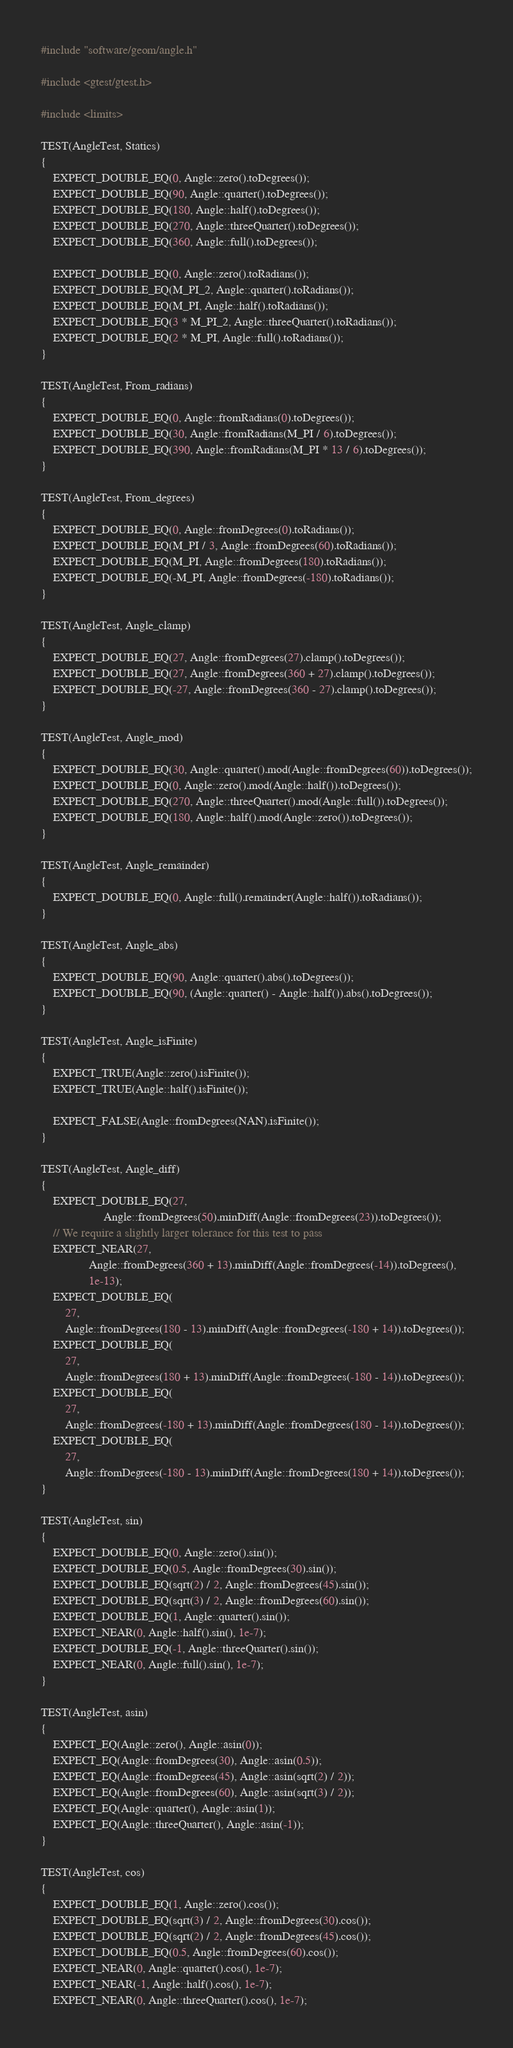<code> <loc_0><loc_0><loc_500><loc_500><_C++_>#include "software/geom/angle.h"

#include <gtest/gtest.h>

#include <limits>

TEST(AngleTest, Statics)
{
    EXPECT_DOUBLE_EQ(0, Angle::zero().toDegrees());
    EXPECT_DOUBLE_EQ(90, Angle::quarter().toDegrees());
    EXPECT_DOUBLE_EQ(180, Angle::half().toDegrees());
    EXPECT_DOUBLE_EQ(270, Angle::threeQuarter().toDegrees());
    EXPECT_DOUBLE_EQ(360, Angle::full().toDegrees());

    EXPECT_DOUBLE_EQ(0, Angle::zero().toRadians());
    EXPECT_DOUBLE_EQ(M_PI_2, Angle::quarter().toRadians());
    EXPECT_DOUBLE_EQ(M_PI, Angle::half().toRadians());
    EXPECT_DOUBLE_EQ(3 * M_PI_2, Angle::threeQuarter().toRadians());
    EXPECT_DOUBLE_EQ(2 * M_PI, Angle::full().toRadians());
}

TEST(AngleTest, From_radians)
{
    EXPECT_DOUBLE_EQ(0, Angle::fromRadians(0).toDegrees());
    EXPECT_DOUBLE_EQ(30, Angle::fromRadians(M_PI / 6).toDegrees());
    EXPECT_DOUBLE_EQ(390, Angle::fromRadians(M_PI * 13 / 6).toDegrees());
}

TEST(AngleTest, From_degrees)
{
    EXPECT_DOUBLE_EQ(0, Angle::fromDegrees(0).toRadians());
    EXPECT_DOUBLE_EQ(M_PI / 3, Angle::fromDegrees(60).toRadians());
    EXPECT_DOUBLE_EQ(M_PI, Angle::fromDegrees(180).toRadians());
    EXPECT_DOUBLE_EQ(-M_PI, Angle::fromDegrees(-180).toRadians());
}

TEST(AngleTest, Angle_clamp)
{
    EXPECT_DOUBLE_EQ(27, Angle::fromDegrees(27).clamp().toDegrees());
    EXPECT_DOUBLE_EQ(27, Angle::fromDegrees(360 + 27).clamp().toDegrees());
    EXPECT_DOUBLE_EQ(-27, Angle::fromDegrees(360 - 27).clamp().toDegrees());
}

TEST(AngleTest, Angle_mod)
{
    EXPECT_DOUBLE_EQ(30, Angle::quarter().mod(Angle::fromDegrees(60)).toDegrees());
    EXPECT_DOUBLE_EQ(0, Angle::zero().mod(Angle::half()).toDegrees());
    EXPECT_DOUBLE_EQ(270, Angle::threeQuarter().mod(Angle::full()).toDegrees());
    EXPECT_DOUBLE_EQ(180, Angle::half().mod(Angle::zero()).toDegrees());
}

TEST(AngleTest, Angle_remainder)
{
    EXPECT_DOUBLE_EQ(0, Angle::full().remainder(Angle::half()).toRadians());
}

TEST(AngleTest, Angle_abs)
{
    EXPECT_DOUBLE_EQ(90, Angle::quarter().abs().toDegrees());
    EXPECT_DOUBLE_EQ(90, (Angle::quarter() - Angle::half()).abs().toDegrees());
}

TEST(AngleTest, Angle_isFinite)
{
    EXPECT_TRUE(Angle::zero().isFinite());
    EXPECT_TRUE(Angle::half().isFinite());

    EXPECT_FALSE(Angle::fromDegrees(NAN).isFinite());
}

TEST(AngleTest, Angle_diff)
{
    EXPECT_DOUBLE_EQ(27,
                     Angle::fromDegrees(50).minDiff(Angle::fromDegrees(23)).toDegrees());
    // We require a slightly larger tolerance for this test to pass
    EXPECT_NEAR(27,
                Angle::fromDegrees(360 + 13).minDiff(Angle::fromDegrees(-14)).toDegrees(),
                1e-13);
    EXPECT_DOUBLE_EQ(
        27,
        Angle::fromDegrees(180 - 13).minDiff(Angle::fromDegrees(-180 + 14)).toDegrees());
    EXPECT_DOUBLE_EQ(
        27,
        Angle::fromDegrees(180 + 13).minDiff(Angle::fromDegrees(-180 - 14)).toDegrees());
    EXPECT_DOUBLE_EQ(
        27,
        Angle::fromDegrees(-180 + 13).minDiff(Angle::fromDegrees(180 - 14)).toDegrees());
    EXPECT_DOUBLE_EQ(
        27,
        Angle::fromDegrees(-180 - 13).minDiff(Angle::fromDegrees(180 + 14)).toDegrees());
}

TEST(AngleTest, sin)
{
    EXPECT_DOUBLE_EQ(0, Angle::zero().sin());
    EXPECT_DOUBLE_EQ(0.5, Angle::fromDegrees(30).sin());
    EXPECT_DOUBLE_EQ(sqrt(2) / 2, Angle::fromDegrees(45).sin());
    EXPECT_DOUBLE_EQ(sqrt(3) / 2, Angle::fromDegrees(60).sin());
    EXPECT_DOUBLE_EQ(1, Angle::quarter().sin());
    EXPECT_NEAR(0, Angle::half().sin(), 1e-7);
    EXPECT_DOUBLE_EQ(-1, Angle::threeQuarter().sin());
    EXPECT_NEAR(0, Angle::full().sin(), 1e-7);
}

TEST(AngleTest, asin)
{
    EXPECT_EQ(Angle::zero(), Angle::asin(0));
    EXPECT_EQ(Angle::fromDegrees(30), Angle::asin(0.5));
    EXPECT_EQ(Angle::fromDegrees(45), Angle::asin(sqrt(2) / 2));
    EXPECT_EQ(Angle::fromDegrees(60), Angle::asin(sqrt(3) / 2));
    EXPECT_EQ(Angle::quarter(), Angle::asin(1));
    EXPECT_EQ(Angle::threeQuarter(), Angle::asin(-1));
}

TEST(AngleTest, cos)
{
    EXPECT_DOUBLE_EQ(1, Angle::zero().cos());
    EXPECT_DOUBLE_EQ(sqrt(3) / 2, Angle::fromDegrees(30).cos());
    EXPECT_DOUBLE_EQ(sqrt(2) / 2, Angle::fromDegrees(45).cos());
    EXPECT_DOUBLE_EQ(0.5, Angle::fromDegrees(60).cos());
    EXPECT_NEAR(0, Angle::quarter().cos(), 1e-7);
    EXPECT_NEAR(-1, Angle::half().cos(), 1e-7);
    EXPECT_NEAR(0, Angle::threeQuarter().cos(), 1e-7);</code> 